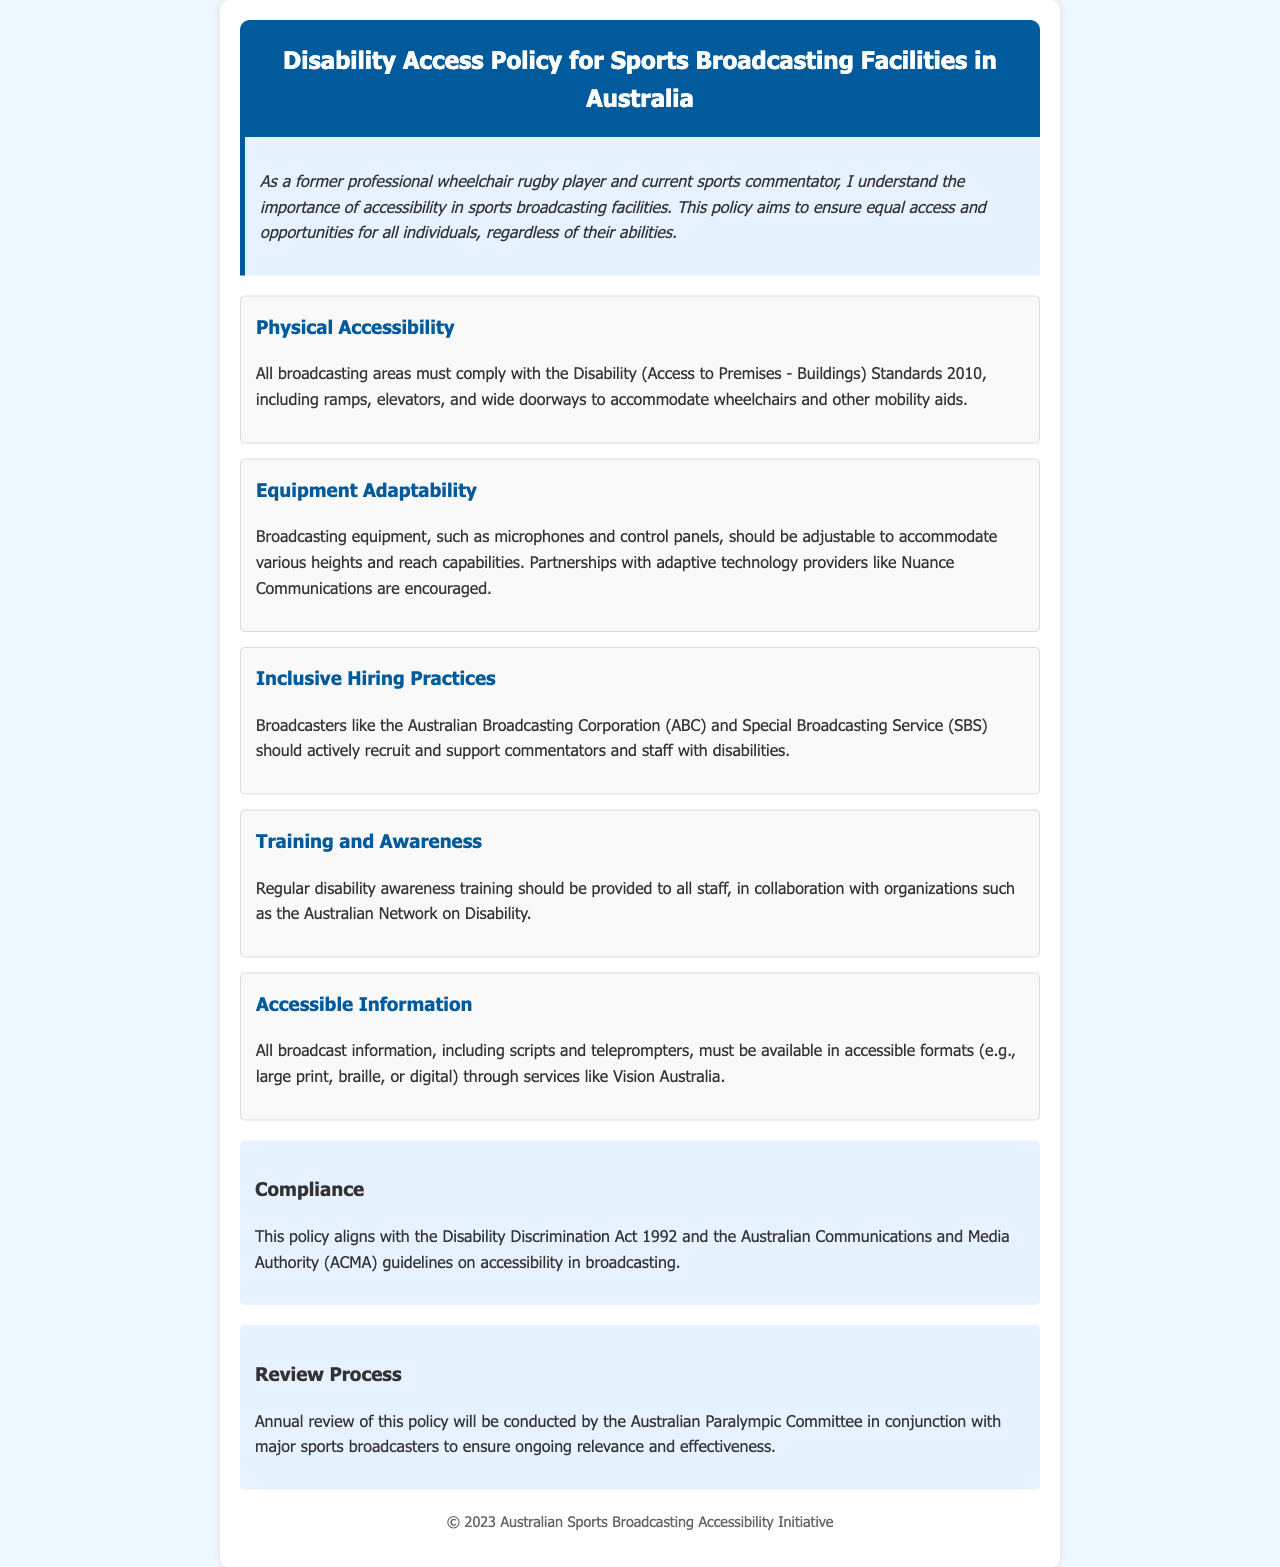What is the title of the policy document? The title is explicitly stated in the header of the document.
Answer: Disability Access Policy for Sports Broadcasting Facilities in Australia What is the main goal of this policy? The main goal is mentioned in the introductory section.
Answer: Ensure equal access and opportunities for all individuals Which standards must broadcasting areas comply with? The standards are listed under the Physical Accessibility section.
Answer: Disability (Access to Premises - Buildings) Standards 2010 Which organization is encouraged to be partnered with for adaptive technology? The partnership is mentioned in the Equipment Adaptability section.
Answer: Nuance Communications What does the policy encourage in terms of hiring practices? The encouragement is found under Inclusive Hiring Practices.
Answer: Actively recruit and support commentators and staff with disabilities What type of training should be provided to staff? The type of training is specified in the Training and Awareness section.
Answer: Disability awareness training How often will the policy be reviewed? The frequency of the review is mentioned in the Review Process section.
Answer: Annually Which act does this policy align with? The act is stated in the Compliance section.
Answer: Disability Discrimination Act 1992 Who will conduct the annual review of the policy? The entity responsible for the review is mentioned in the Review Process section.
Answer: Australian Paralympic Committee 